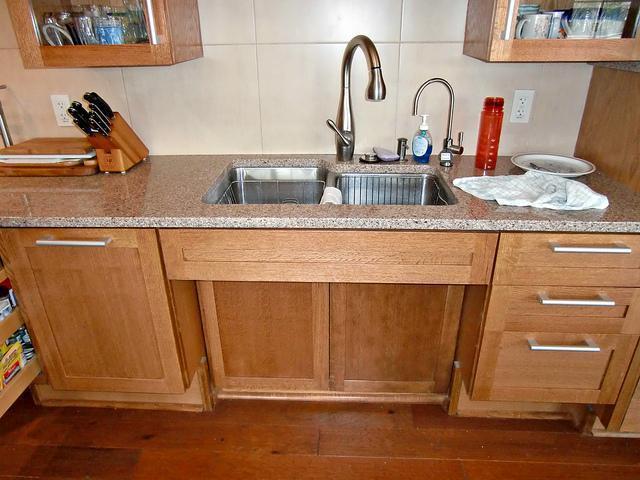How many sinks are in the picture?
Give a very brief answer. 2. How many cars are there?
Give a very brief answer. 0. 